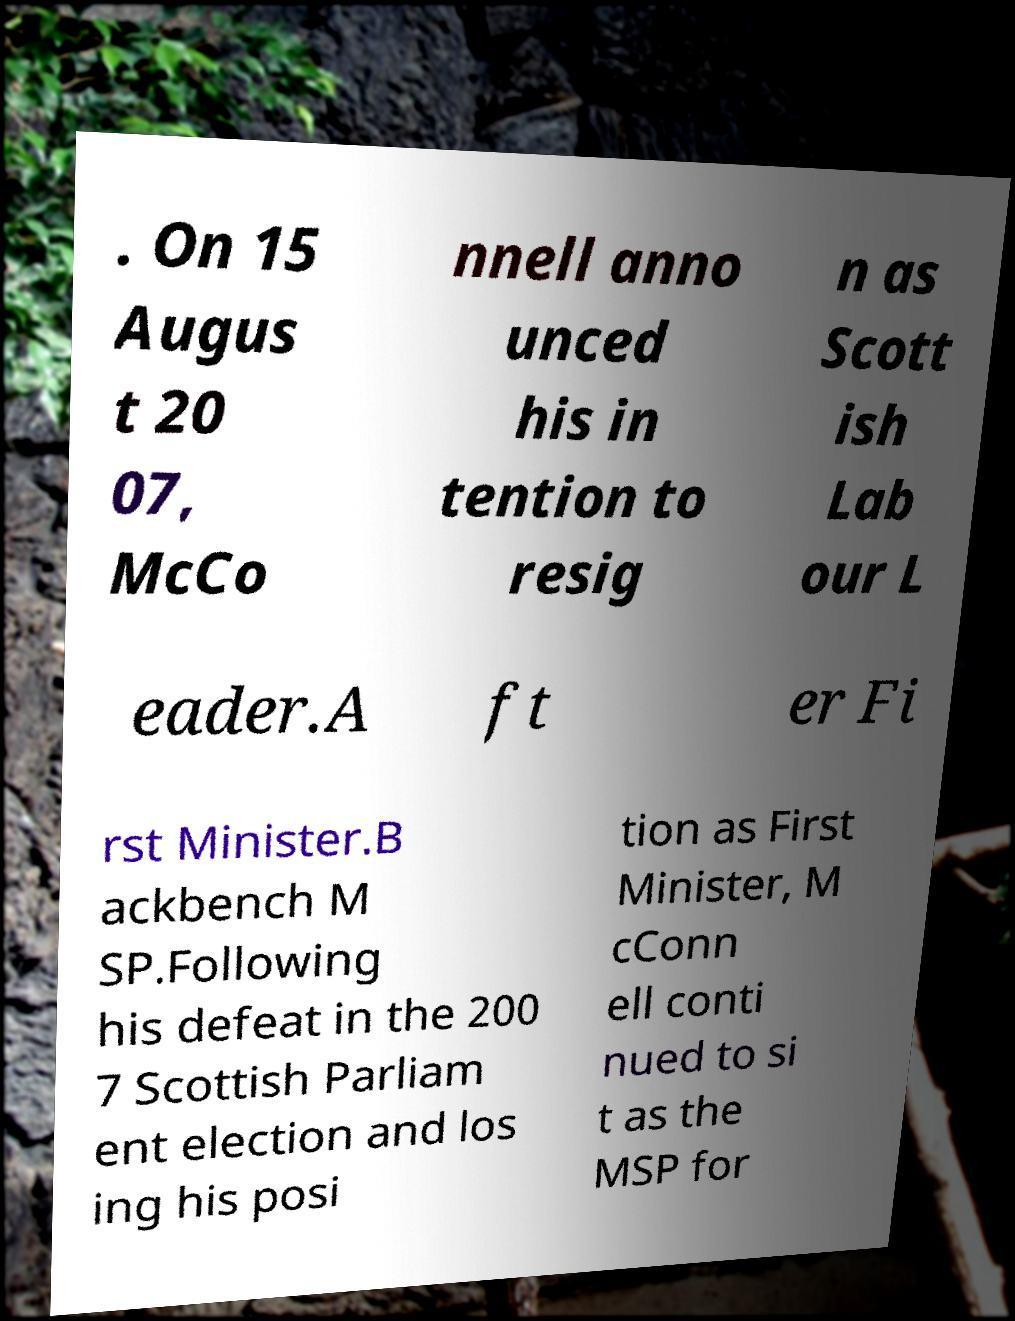Please identify and transcribe the text found in this image. . On 15 Augus t 20 07, McCo nnell anno unced his in tention to resig n as Scott ish Lab our L eader.A ft er Fi rst Minister.B ackbench M SP.Following his defeat in the 200 7 Scottish Parliam ent election and los ing his posi tion as First Minister, M cConn ell conti nued to si t as the MSP for 